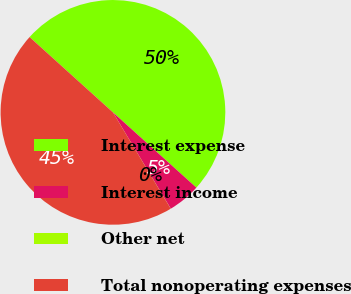Convert chart. <chart><loc_0><loc_0><loc_500><loc_500><pie_chart><fcel>Interest expense<fcel>Interest income<fcel>Other net<fcel>Total nonoperating expenses<nl><fcel>49.99%<fcel>4.71%<fcel>0.01%<fcel>45.29%<nl></chart> 